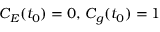<formula> <loc_0><loc_0><loc_500><loc_500>C _ { E } ( t _ { 0 } ) = 0 , \, C _ { g } ( t _ { 0 } ) = 1</formula> 